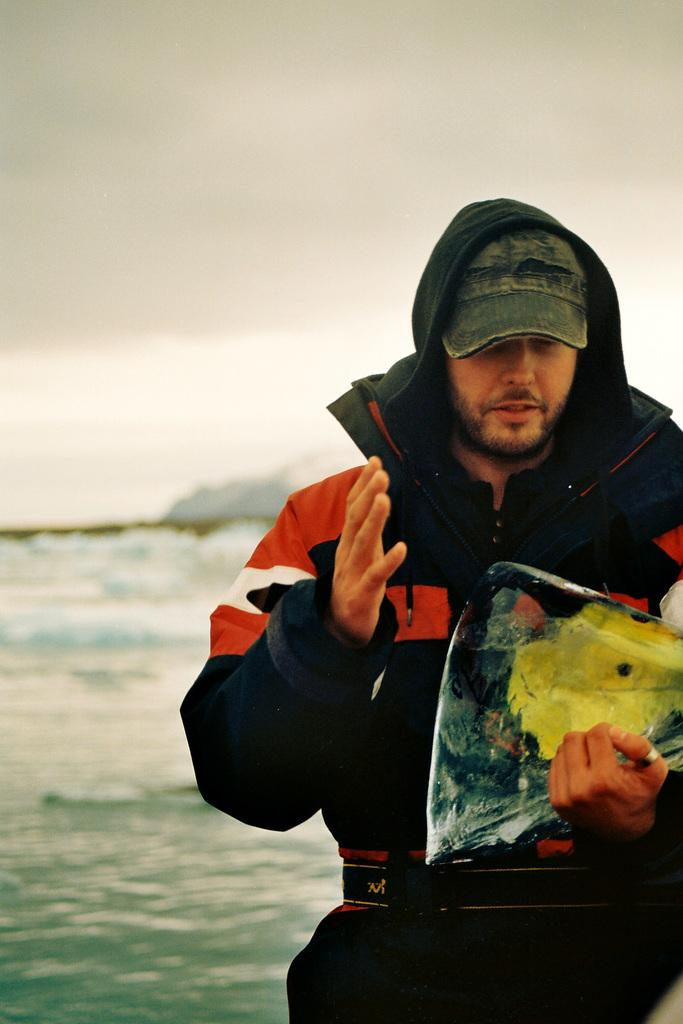What is the person doing on the right side of the image? The person is standing on the right side of the image. What is the person holding in the image? The person is holding an object in the image. What can be seen in the background of the image? There is a sea in the background of the image. What is visible at the top of the image? The sky is visible at the top of the image. What type of wool is being used to create the truck in the image? There is no wool or truck present in the image. 